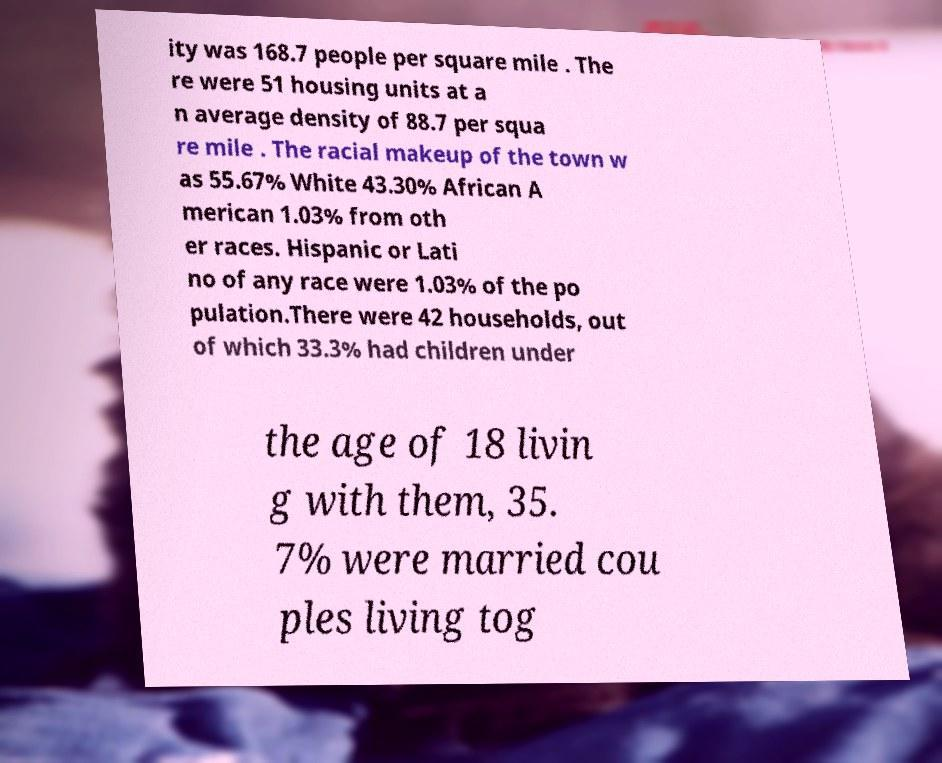Could you extract and type out the text from this image? ity was 168.7 people per square mile . The re were 51 housing units at a n average density of 88.7 per squa re mile . The racial makeup of the town w as 55.67% White 43.30% African A merican 1.03% from oth er races. Hispanic or Lati no of any race were 1.03% of the po pulation.There were 42 households, out of which 33.3% had children under the age of 18 livin g with them, 35. 7% were married cou ples living tog 